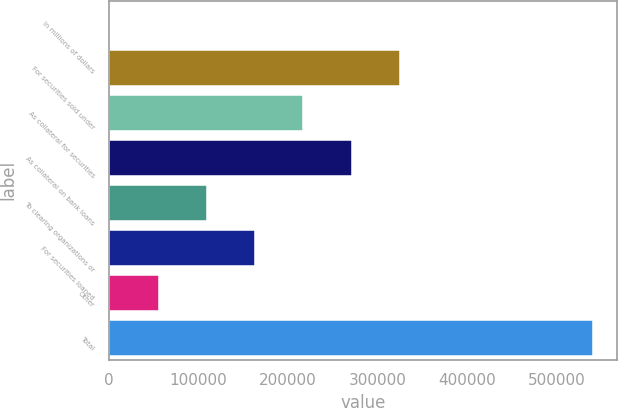Convert chart to OTSL. <chart><loc_0><loc_0><loc_500><loc_500><bar_chart><fcel>In millions of dollars<fcel>For securities sold under<fcel>As collateral for securities<fcel>As collateral on bank loans<fcel>To clearing organizations or<fcel>For securities loaned<fcel>Other<fcel>Total<nl><fcel>2010<fcel>324655<fcel>217107<fcel>270881<fcel>109558<fcel>163333<fcel>55784.2<fcel>539752<nl></chart> 